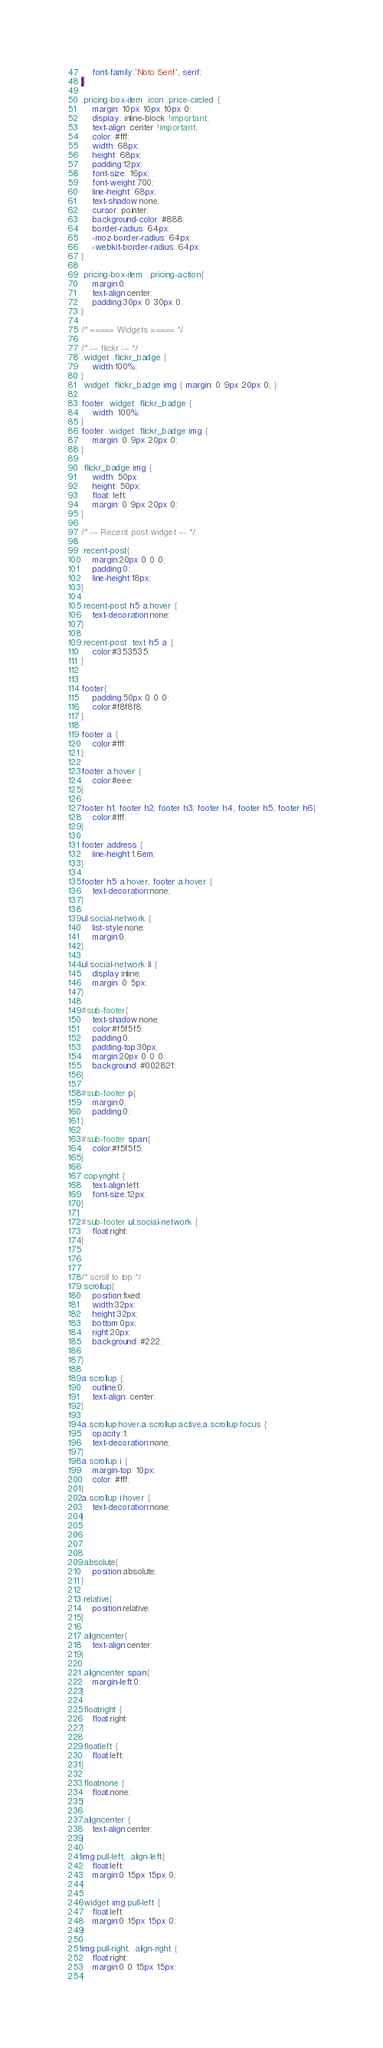Convert code to text. <code><loc_0><loc_0><loc_500><loc_500><_CSS_>	font-family:'Noto Serif', serif;
}

.pricing-box-item .icon .price-circled {
    margin: 10px 10px 10px 0;
    display: inline-block !important;
    text-align: center !important;
    color: #fff;
    width: 68px;
    height: 68px;
	padding:12px;
    font-size: 16px;
	font-weight:700;
    line-height: 68px;
    text-shadow:none;
    cursor: pointer;
    background-color: #888;
    border-radius: 64px;
    -moz-border-radius: 64px;
    -webkit-border-radius: 64px;
}

.pricing-box-item  .pricing-action{
	margin:0;
	text-align:center;
	padding:30px 0 30px 0;
}

/* ===== Widgets ===== */

/* --- flickr --- */
.widget .flickr_badge {
	width:100%;
}
.widget .flickr_badge img { margin: 0 9px 20px 0; }

footer .widget .flickr_badge {
    width: 100%;
}
footer .widget .flickr_badge img {
    margin: 0 9px 20px 0;
}

.flickr_badge img {
    width: 50px;
    height: 50px;
    float: left;
	margin: 0 9px 20px 0;
}

/* --- Recent post widget --- */

.recent-post{
	margin:20px 0 0 0;
	padding:0;
	line-height:18px;
}

.recent-post h5 a:hover {
	text-decoration:none;
}

.recent-post .text h5 a {
	color:#353535;
}


footer{
	padding:50px 0 0 0;
	color:#f8f8f8;
}

footer a {
	color:#fff;
}

footer a:hover {
	color:#eee;
}

footer h1, footer h2, footer h3, footer h4, footer h5, footer h6{
	color:#fff;
}

footer address {
	line-height:1.6em;
}

footer h5 a:hover, footer a:hover {
	text-decoration:none;
}

ul.social-network {
	list-style:none;
	margin:0;
}

ul.social-network li {
	display:inline;
	margin: 0 5px;
}

#sub-footer{
	text-shadow:none;
	color:#f5f5f5;
	padding:0;
	padding-top:30px;
	margin:20px 0 0 0;
	background: #002821;
}

#sub-footer p{
	margin:0;
	padding:0;
}

#sub-footer span{
	color:#f5f5f5;
}

.copyright {
	text-align:left;
	font-size:12px;
}

#sub-footer ul.social-network {
	float:right;
}



/* scroll to top */
.scrollup{
    position:fixed;
	width:32px;
	height:32px;
    bottom:0px;
    right:20px;
	background: #222;

}

a.scrollup {
	outline:0;
	text-align: center;
}

a.scrollup:hover,a.scrollup:active,a.scrollup:focus {
	opacity:1;
	text-decoration:none;
}
a.scrollup i {
	margin-top: 10px;
	color: #fff;
}
a.scrollup i:hover {
	text-decoration:none;
}




.absolute{
	position:absolute;
}

.relative{
	position:relative;
}

.aligncenter{
	text-align:center;
}

.aligncenter span{
	margin-left:0;
}

.floatright {
	float:right;
}

.floatleft {
	float:left;
}

.floatnone {
	float:none;
}

.aligncenter {
	text-align:center;
}

img.pull-left, .align-left{
	float:left;
	margin:0 15px 15px 0;
}

.widget img.pull-left {
	float:left;
	margin:0 15px 15px 0;
}

img.pull-right, .align-right {
	float:right;
	margin:0 0 15px 15px;
}
</code> 